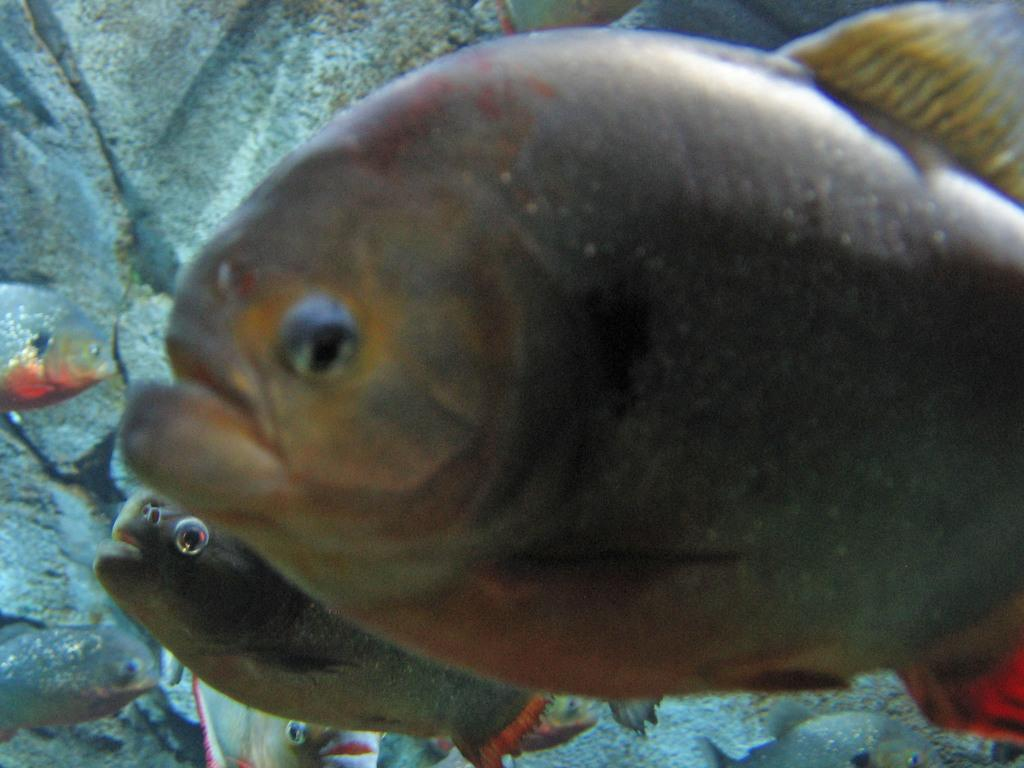What type of animals can be seen in the image? There are fishes in the water. What is visible in the background of the image? There is a rock visible in the background. What type of bag can be seen hanging on the rock in the image? There is no bag present in the image; it only features fishes in the water and a rock in the background. 